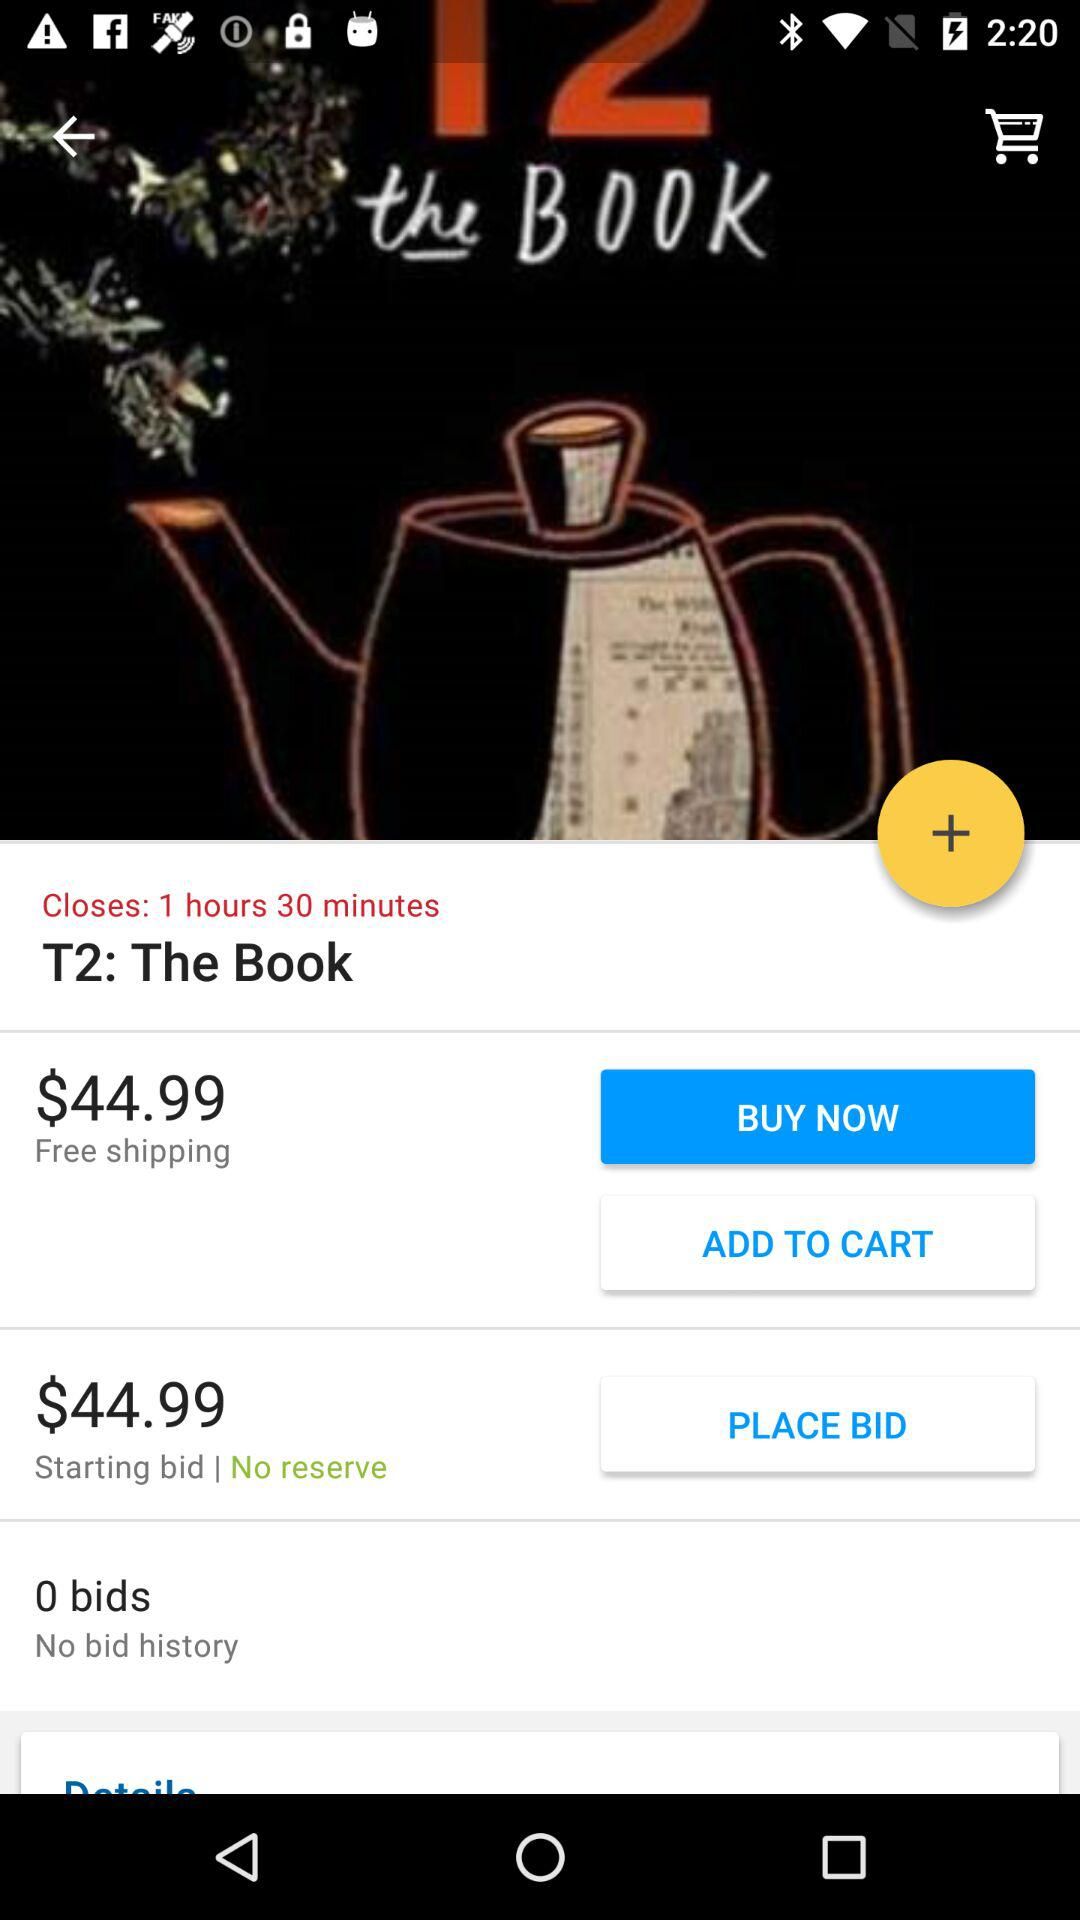How much time is left for closing? There is 1 hour and 30 minutes left for closing. 